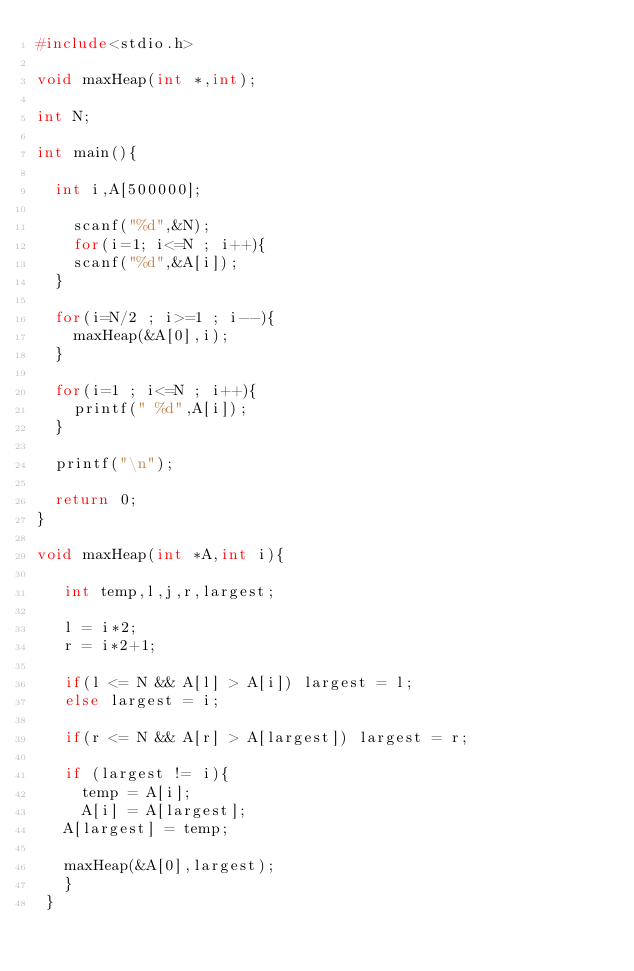<code> <loc_0><loc_0><loc_500><loc_500><_C_>#include<stdio.h>

void maxHeap(int *,int);

int N;

int main(){
  
  int i,A[500000];
  
    scanf("%d",&N);
    for(i=1; i<=N ; i++){
    scanf("%d",&A[i]);
  }
  
  for(i=N/2 ; i>=1 ; i--){
    maxHeap(&A[0],i);
  }
  
  for(i=1 ; i<=N ; i++){
    printf(" %d",A[i]);
  }
  
  printf("\n");
  
  return 0;
}

void maxHeap(int *A,int i){
   
   int temp,l,j,r,largest;
   
   l = i*2;
   r = i*2+1;
   
   if(l <= N && A[l] > A[i]) largest = l;
   else largest = i;
   
   if(r <= N && A[r] > A[largest]) largest = r;
   
   if (largest != i){
     temp = A[i];
     A[i] = A[largest];
   A[largest] = temp;
   
   maxHeap(&A[0],largest);	 
   }
 }

</code> 